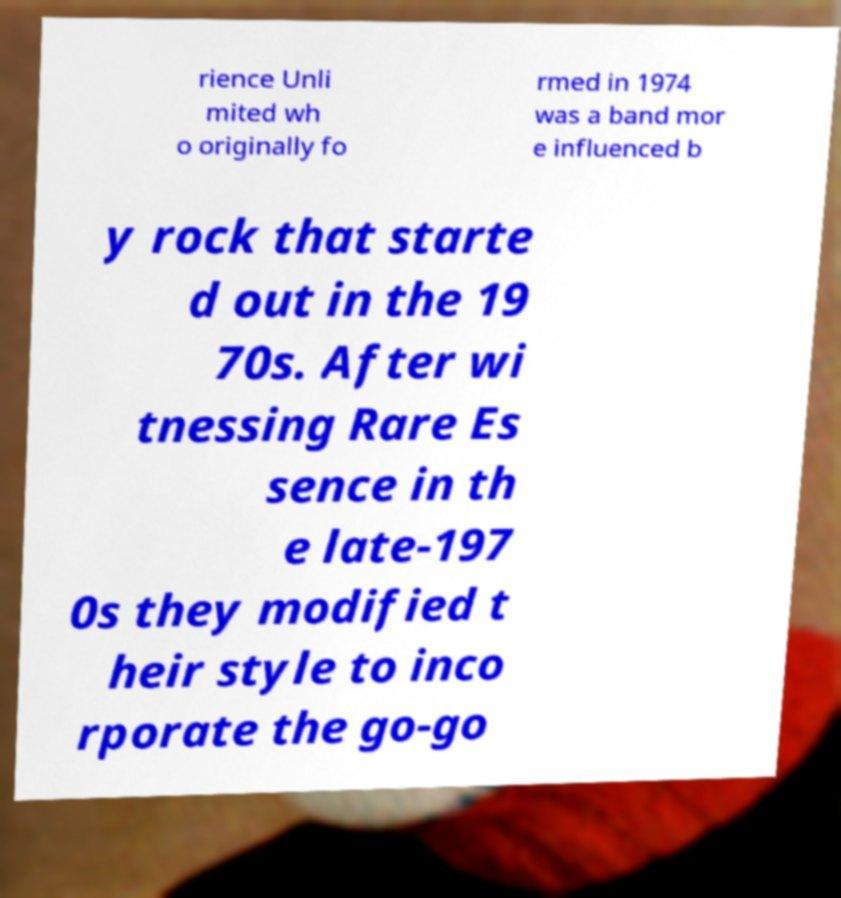For documentation purposes, I need the text within this image transcribed. Could you provide that? rience Unli mited wh o originally fo rmed in 1974 was a band mor e influenced b y rock that starte d out in the 19 70s. After wi tnessing Rare Es sence in th e late-197 0s they modified t heir style to inco rporate the go-go 